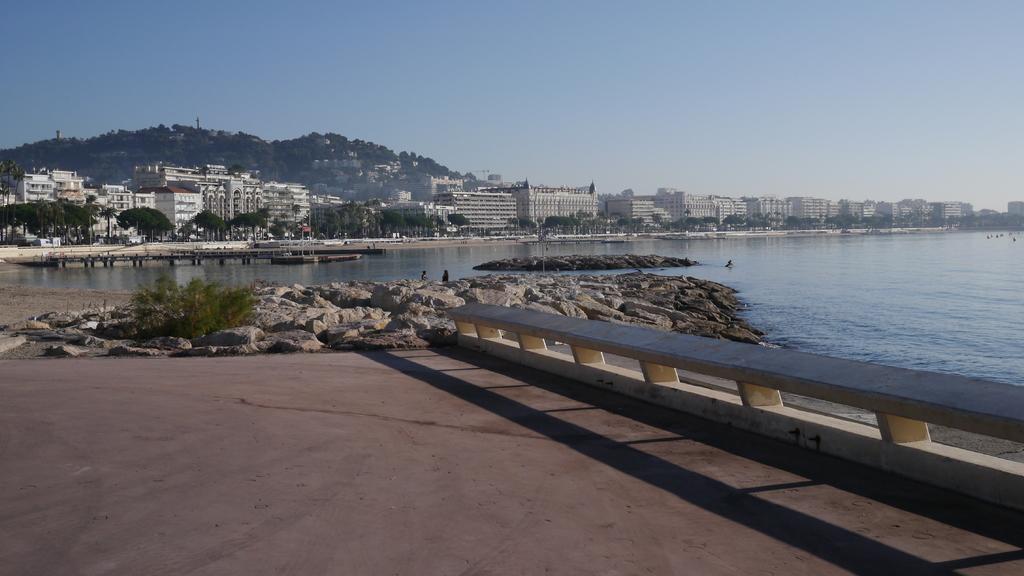Could you give a brief overview of what you see in this image? In this image there are buildings and trees. We can see water. we can see water. On the right there is a fence. In the background there is a hill and sky. 